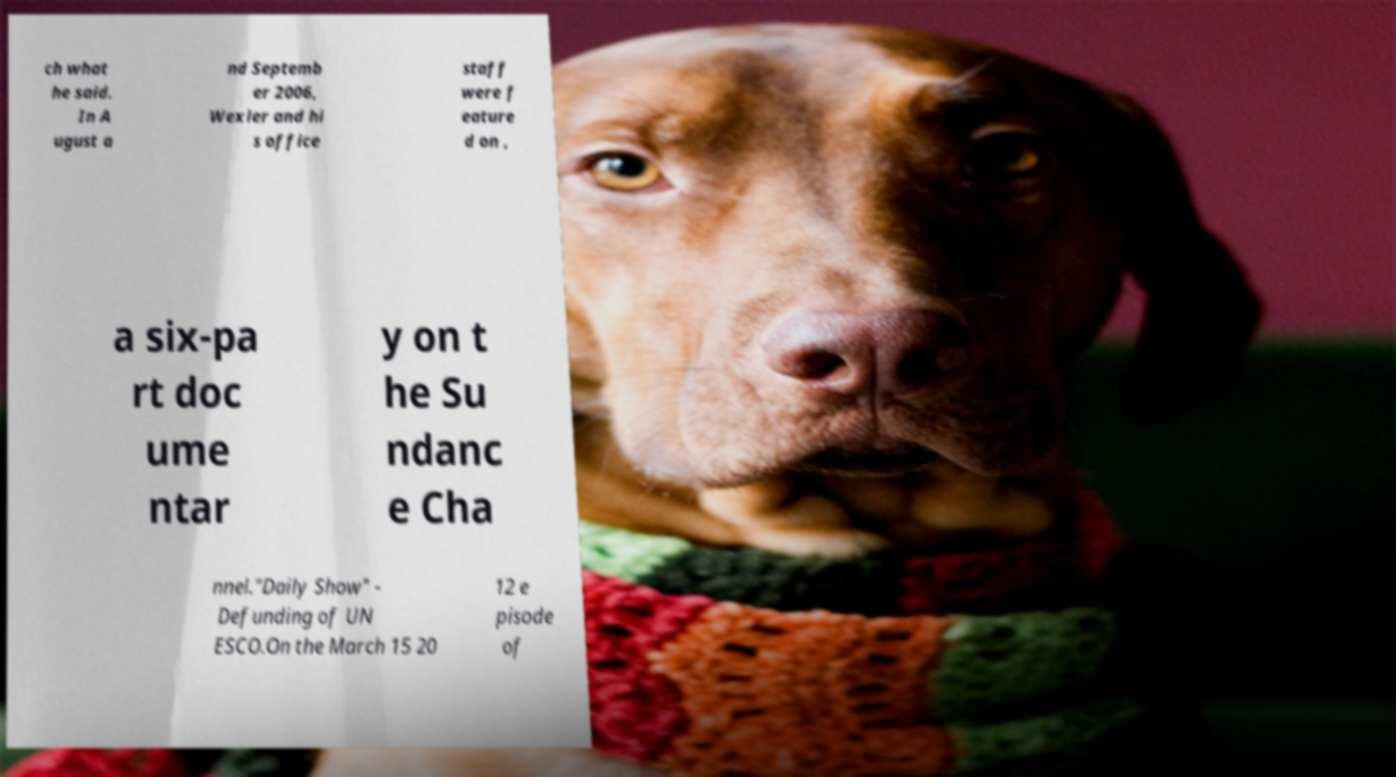Can you accurately transcribe the text from the provided image for me? ch what he said. In A ugust a nd Septemb er 2006, Wexler and hi s office staff were f eature d on , a six-pa rt doc ume ntar y on t he Su ndanc e Cha nnel."Daily Show" - Defunding of UN ESCO.On the March 15 20 12 e pisode of 